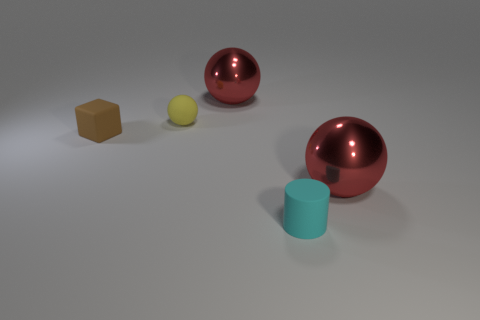How big is the cyan matte cylinder?
Provide a succinct answer. Small. Is the tiny object that is to the right of the matte sphere made of the same material as the tiny brown thing?
Give a very brief answer. Yes. Are there fewer big shiny spheres to the left of the tiny yellow rubber ball than big red things behind the rubber cylinder?
Give a very brief answer. Yes. There is a cyan thing that is the same size as the yellow sphere; what material is it?
Ensure brevity in your answer.  Rubber. Is the number of rubber spheres that are left of the block less than the number of tiny brown metal things?
Give a very brief answer. No. What is the shape of the big red object that is behind the large metal object that is in front of the big sphere that is behind the yellow matte ball?
Keep it short and to the point. Sphere. There is a red ball that is behind the matte block; what size is it?
Your response must be concise. Large. What is the shape of the brown object that is the same size as the cyan matte cylinder?
Provide a succinct answer. Cube. What number of objects are either small cyan rubber cylinders or matte objects on the left side of the cyan cylinder?
Your answer should be very brief. 3. What number of objects are in front of the big red object that is behind the large object in front of the brown rubber cube?
Keep it short and to the point. 4. 